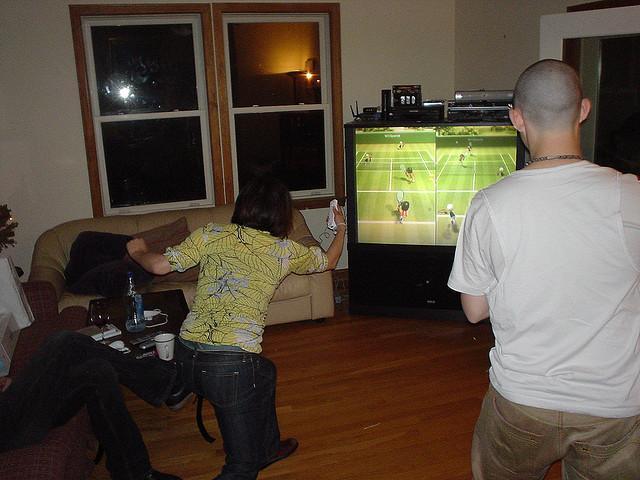How many people can you see?
Give a very brief answer. 3. How many couches are visible?
Give a very brief answer. 2. 